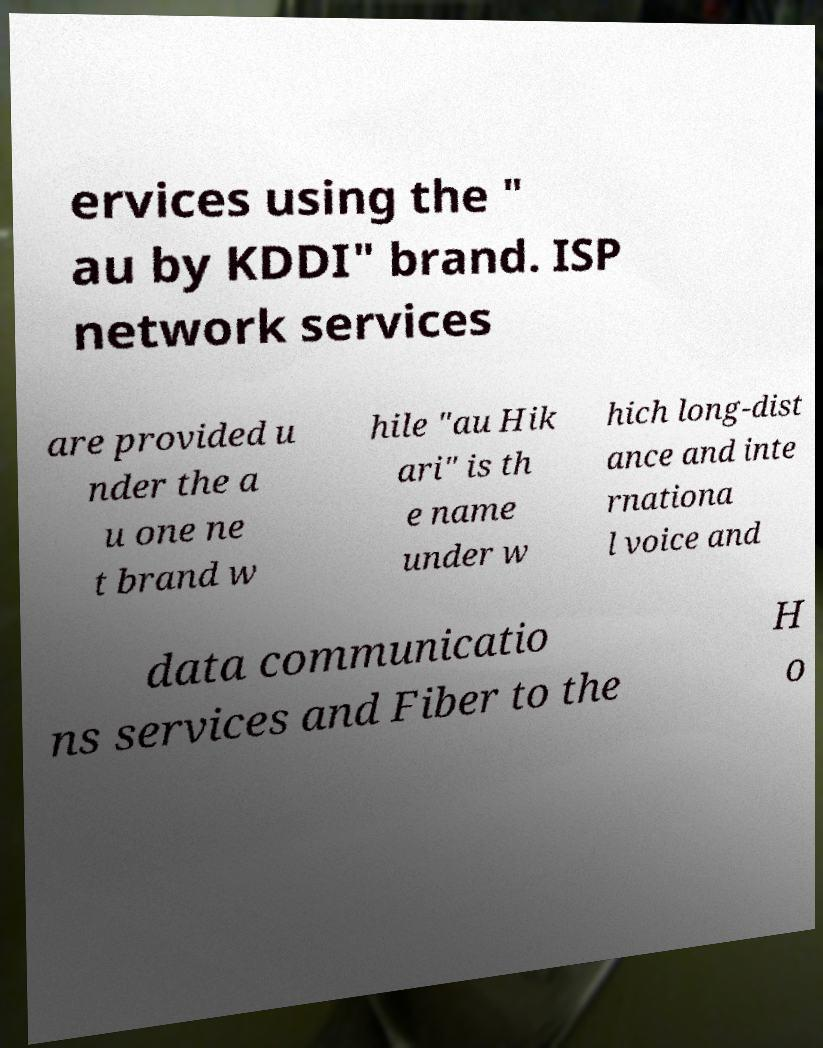For documentation purposes, I need the text within this image transcribed. Could you provide that? ervices using the " au by KDDI" brand. ISP network services are provided u nder the a u one ne t brand w hile "au Hik ari" is th e name under w hich long-dist ance and inte rnationa l voice and data communicatio ns services and Fiber to the H o 